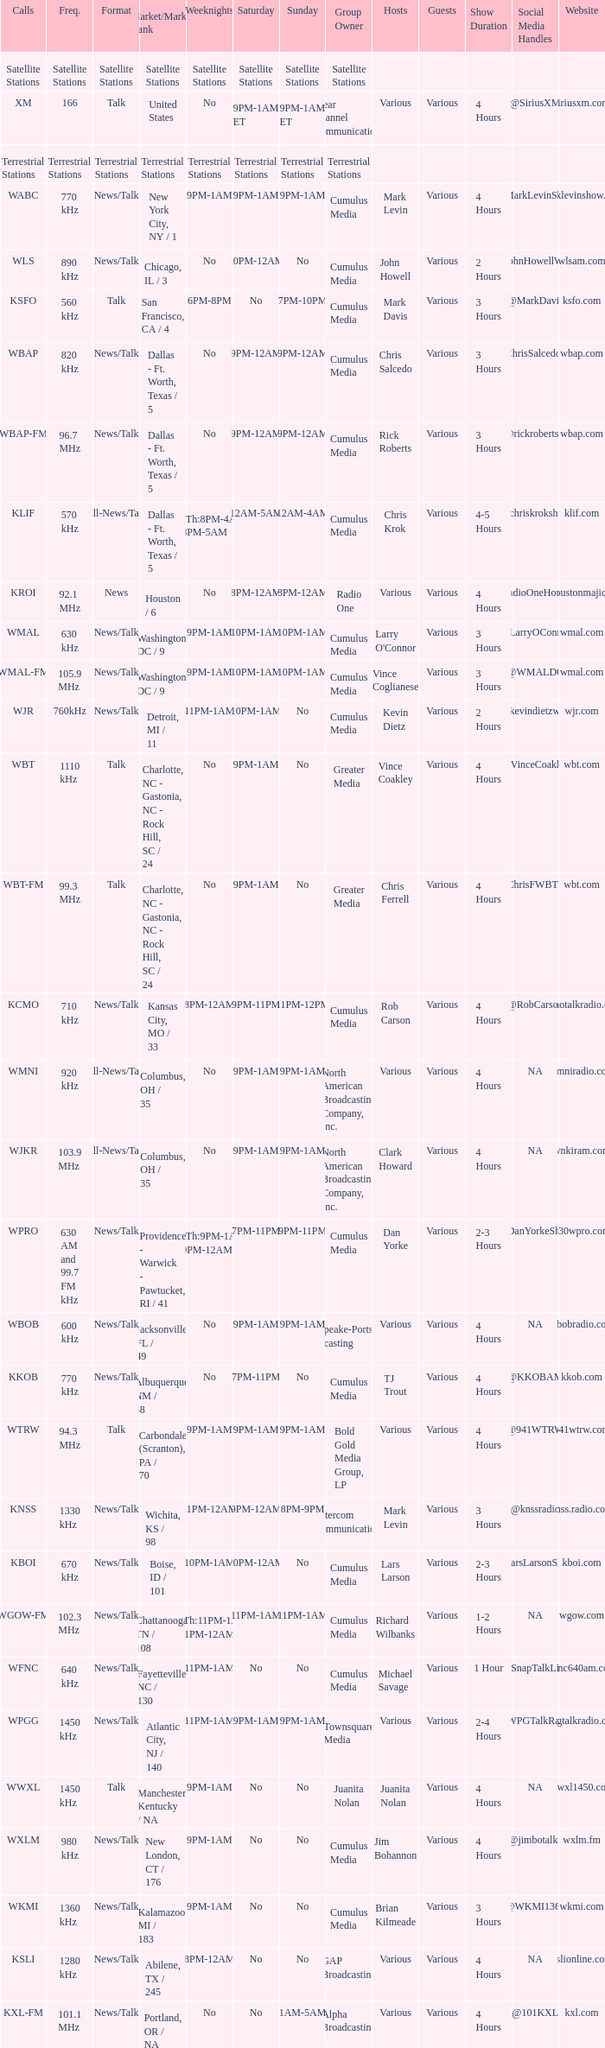What is the market for the 11pm-1am Saturday game? Chattanooga, TN / 108. 